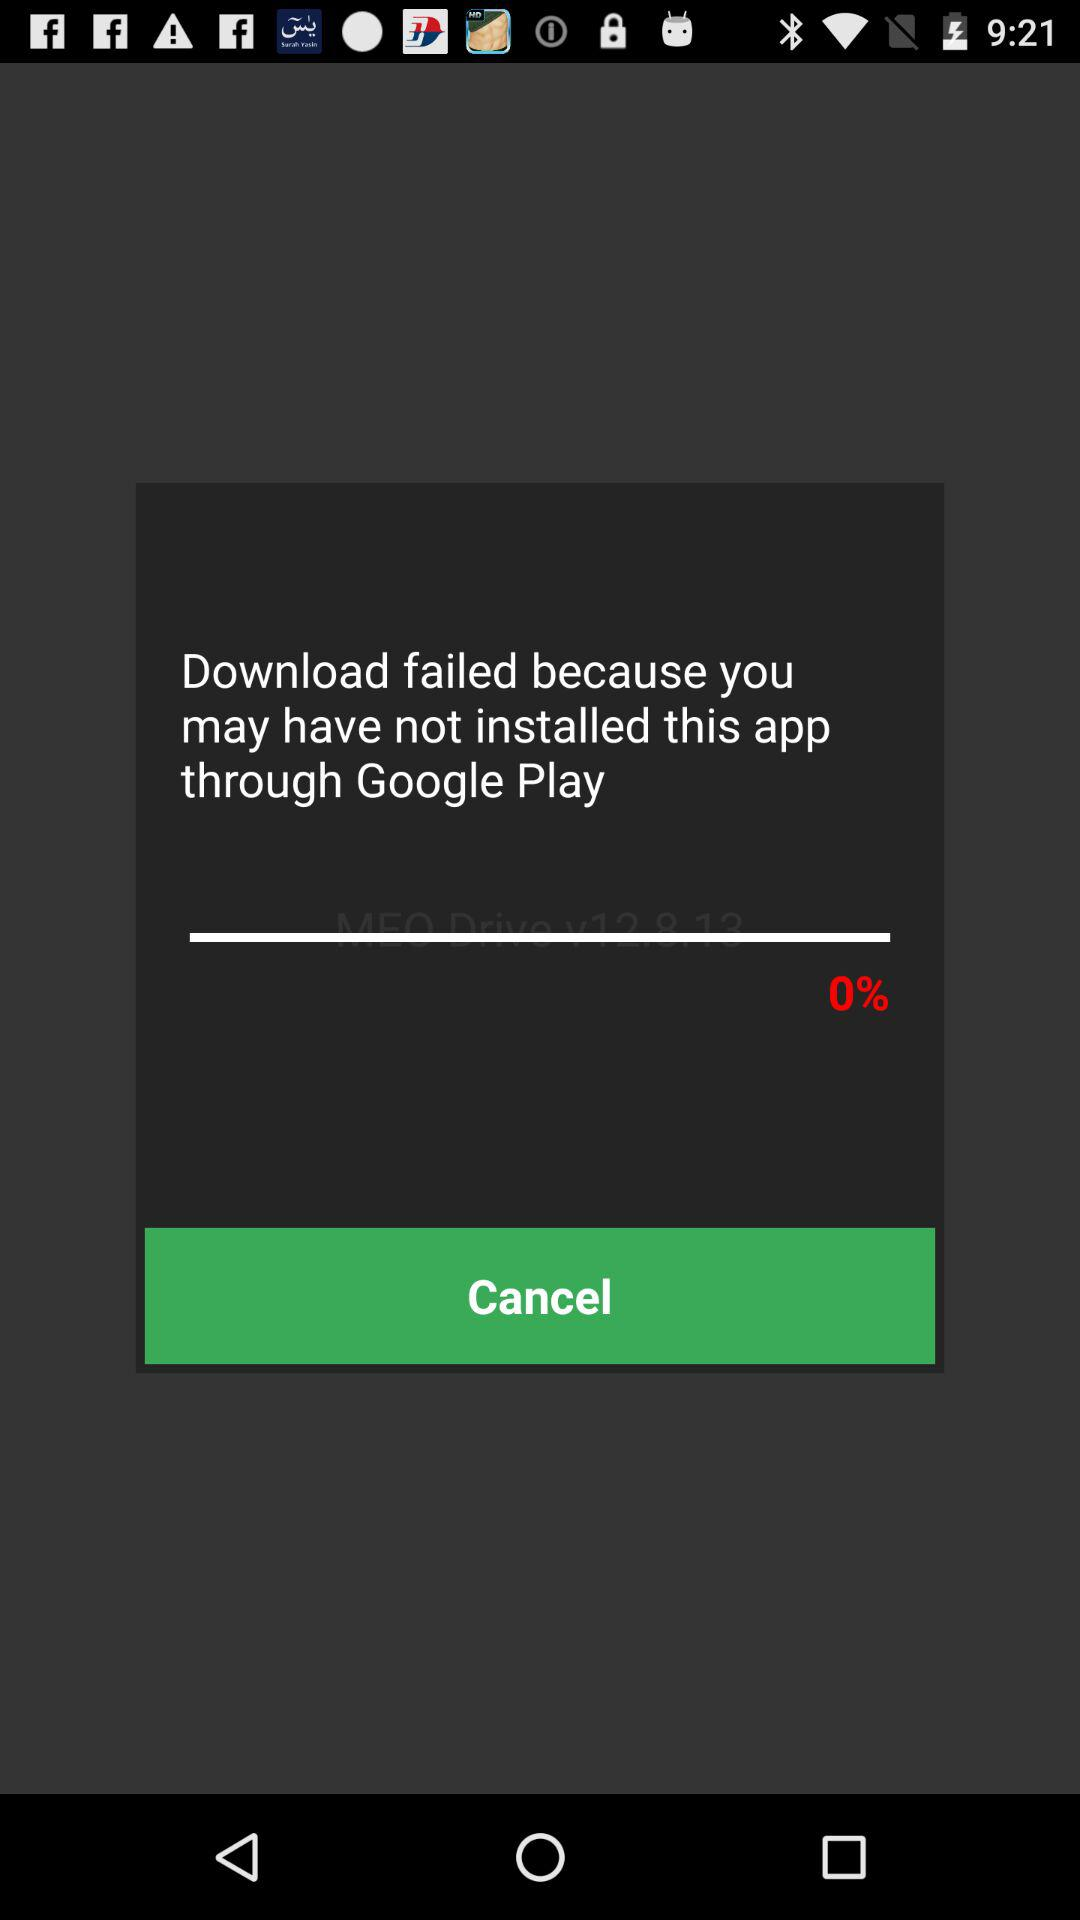How much is loading?
When the provided information is insufficient, respond with <no answer>. <no answer> 